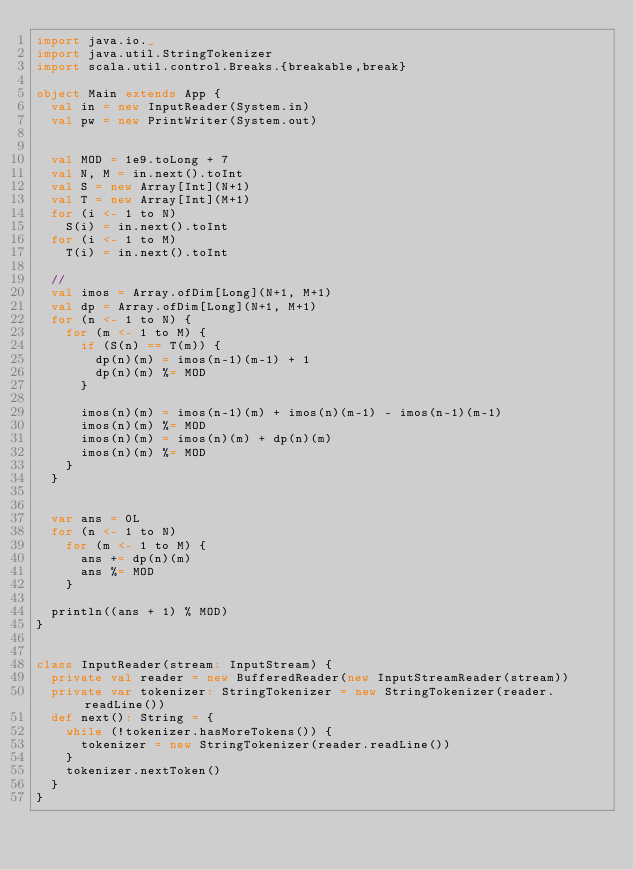<code> <loc_0><loc_0><loc_500><loc_500><_Scala_>import java.io._
import java.util.StringTokenizer
import scala.util.control.Breaks.{breakable,break}

object Main extends App {
  val in = new InputReader(System.in)
  val pw = new PrintWriter(System.out)


  val MOD = 1e9.toLong + 7
  val N, M = in.next().toInt
  val S = new Array[Int](N+1)
  val T = new Array[Int](M+1)
  for (i <- 1 to N)
    S(i) = in.next().toInt
  for (i <- 1 to M)
    T(i) = in.next().toInt

  //
  val imos = Array.ofDim[Long](N+1, M+1)
  val dp = Array.ofDim[Long](N+1, M+1)
  for (n <- 1 to N) {
    for (m <- 1 to M) {
      if (S(n) == T(m)) {
        dp(n)(m) = imos(n-1)(m-1) + 1
        dp(n)(m) %= MOD
      }

      imos(n)(m) = imos(n-1)(m) + imos(n)(m-1) - imos(n-1)(m-1)
      imos(n)(m) %= MOD
      imos(n)(m) = imos(n)(m) + dp(n)(m)
      imos(n)(m) %= MOD
    }
  }


  var ans = 0L
  for (n <- 1 to N)
    for (m <- 1 to M) {
      ans += dp(n)(m)
      ans %= MOD
    }

  println((ans + 1) % MOD)
}


class InputReader(stream: InputStream) {
  private val reader = new BufferedReader(new InputStreamReader(stream))
  private var tokenizer: StringTokenizer = new StringTokenizer(reader.readLine())
  def next(): String = {
    while (!tokenizer.hasMoreTokens()) {
      tokenizer = new StringTokenizer(reader.readLine())
    }
    tokenizer.nextToken()
  }
}
</code> 